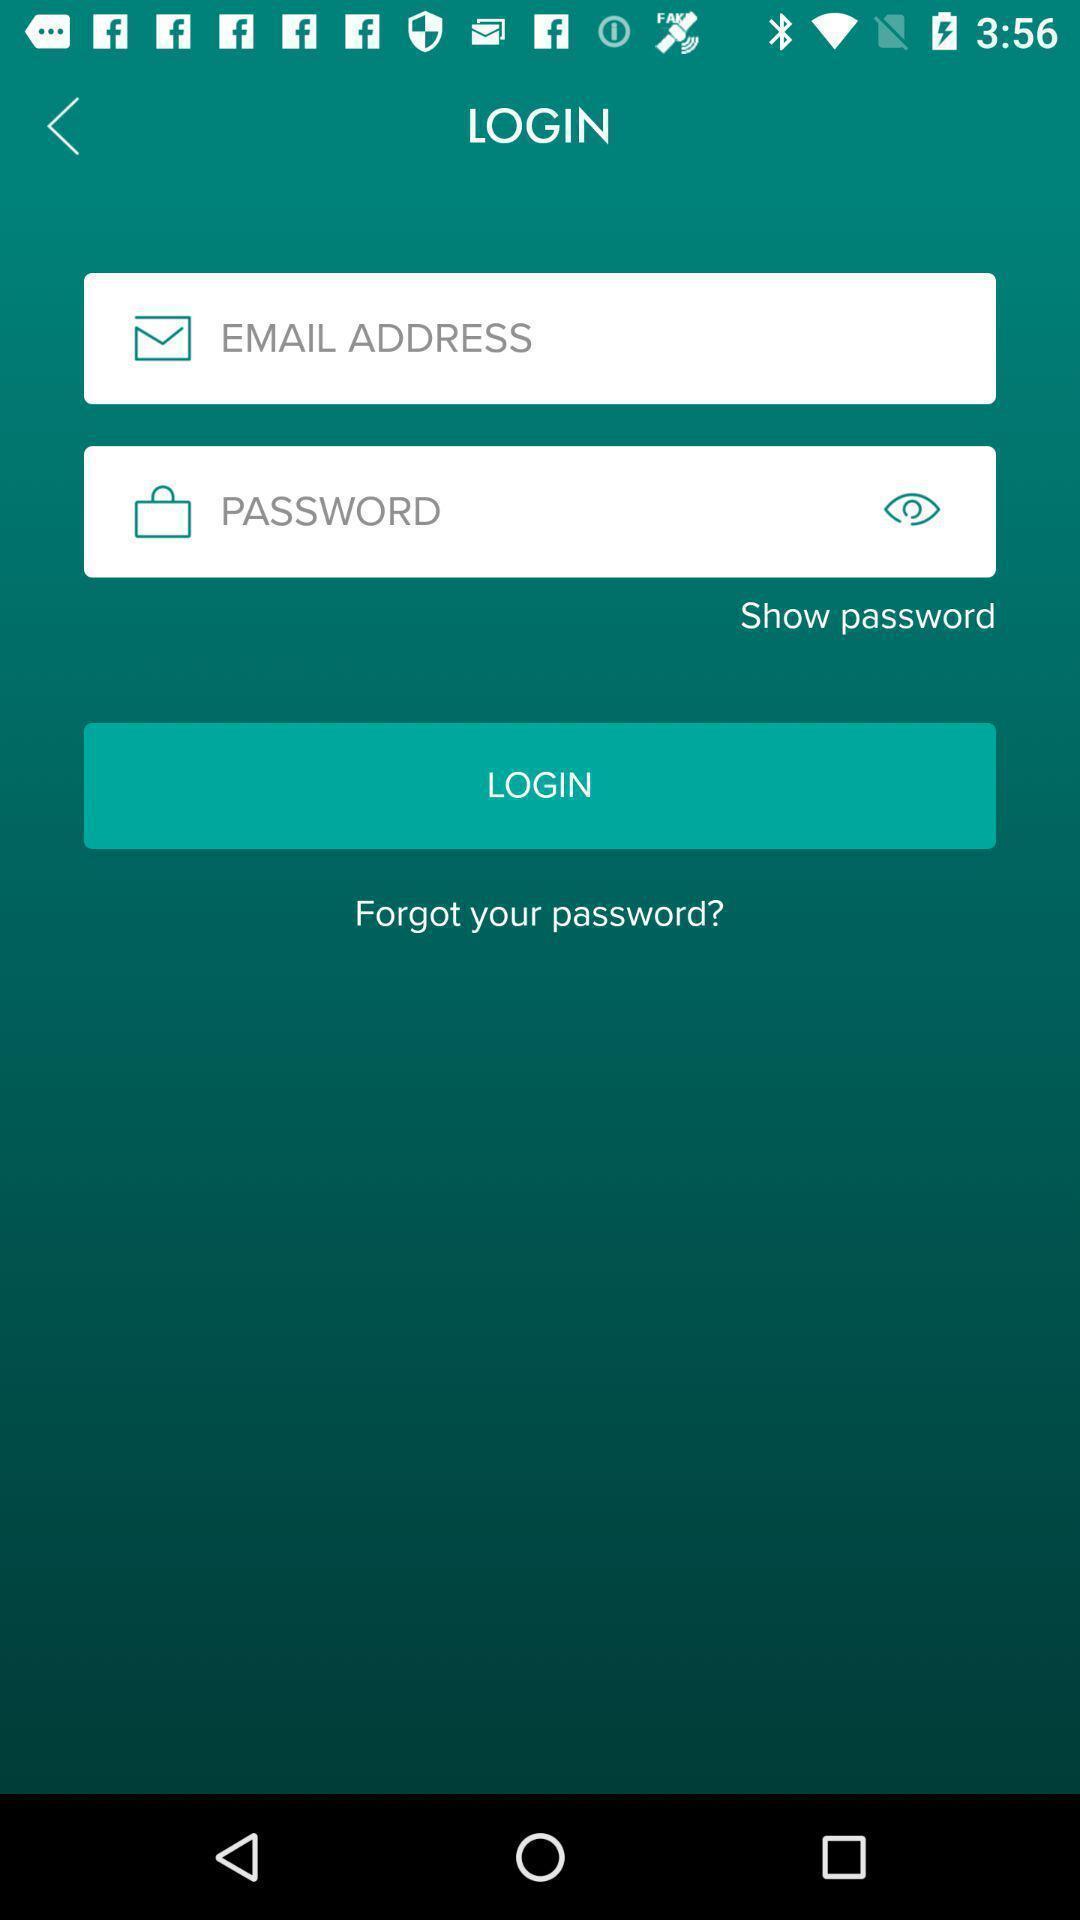What can you discern from this picture? Page displaying information to enter and login. 